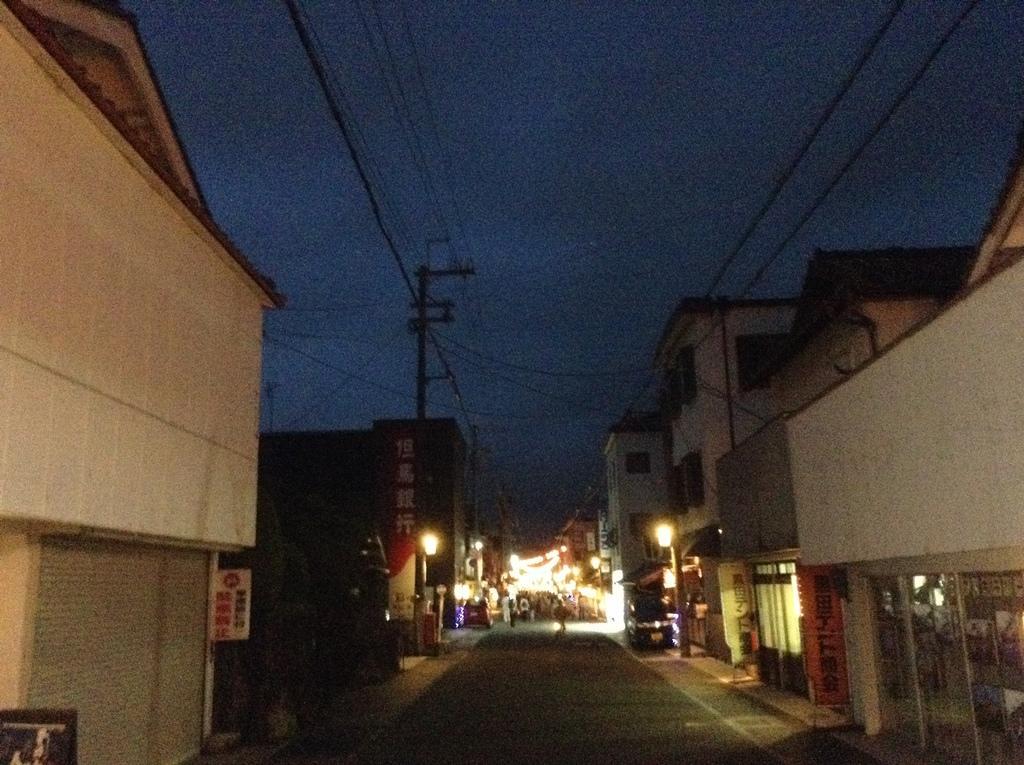Can you describe this image briefly? In this image we can see some buildings, the sign boards with some text on them, an utility pole with wires, poles, lights and the sky. 